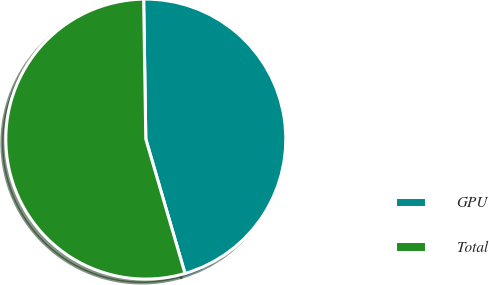Convert chart to OTSL. <chart><loc_0><loc_0><loc_500><loc_500><pie_chart><fcel>GPU<fcel>Total<nl><fcel>45.73%<fcel>54.27%<nl></chart> 